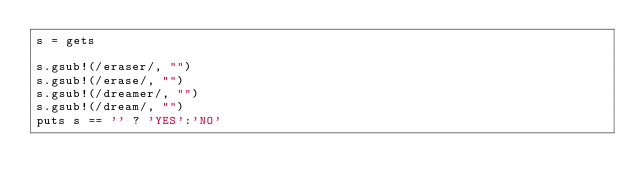Convert code to text. <code><loc_0><loc_0><loc_500><loc_500><_Ruby_>s = gets
 
s.gsub!(/eraser/, "")
s.gsub!(/erase/, "")
s.gsub!(/dreamer/, "")
s.gsub!(/dream/, "")
puts s == '' ? 'YES':'NO'</code> 